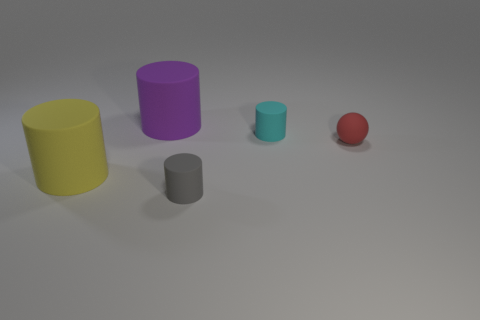Is the material of the yellow cylinder the same as the small ball?
Your answer should be compact. Yes. What number of objects are either big green metal cylinders or big cylinders?
Your answer should be compact. 2. The purple cylinder is what size?
Give a very brief answer. Large. Is the number of tiny balls less than the number of matte cylinders?
Give a very brief answer. Yes. There is a red matte thing that is behind the yellow thing; what is its shape?
Offer a very short reply. Sphere. Are there any cylinders in front of the cylinder right of the gray rubber cylinder?
Make the answer very short. Yes. What number of spheres are the same material as the small gray object?
Make the answer very short. 1. How big is the cylinder that is on the right side of the small matte cylinder in front of the large rubber cylinder that is in front of the large purple object?
Provide a short and direct response. Small. There is a big purple cylinder; how many big yellow rubber cylinders are to the left of it?
Offer a terse response. 1. Is the number of cyan cylinders greater than the number of green cylinders?
Keep it short and to the point. Yes. 